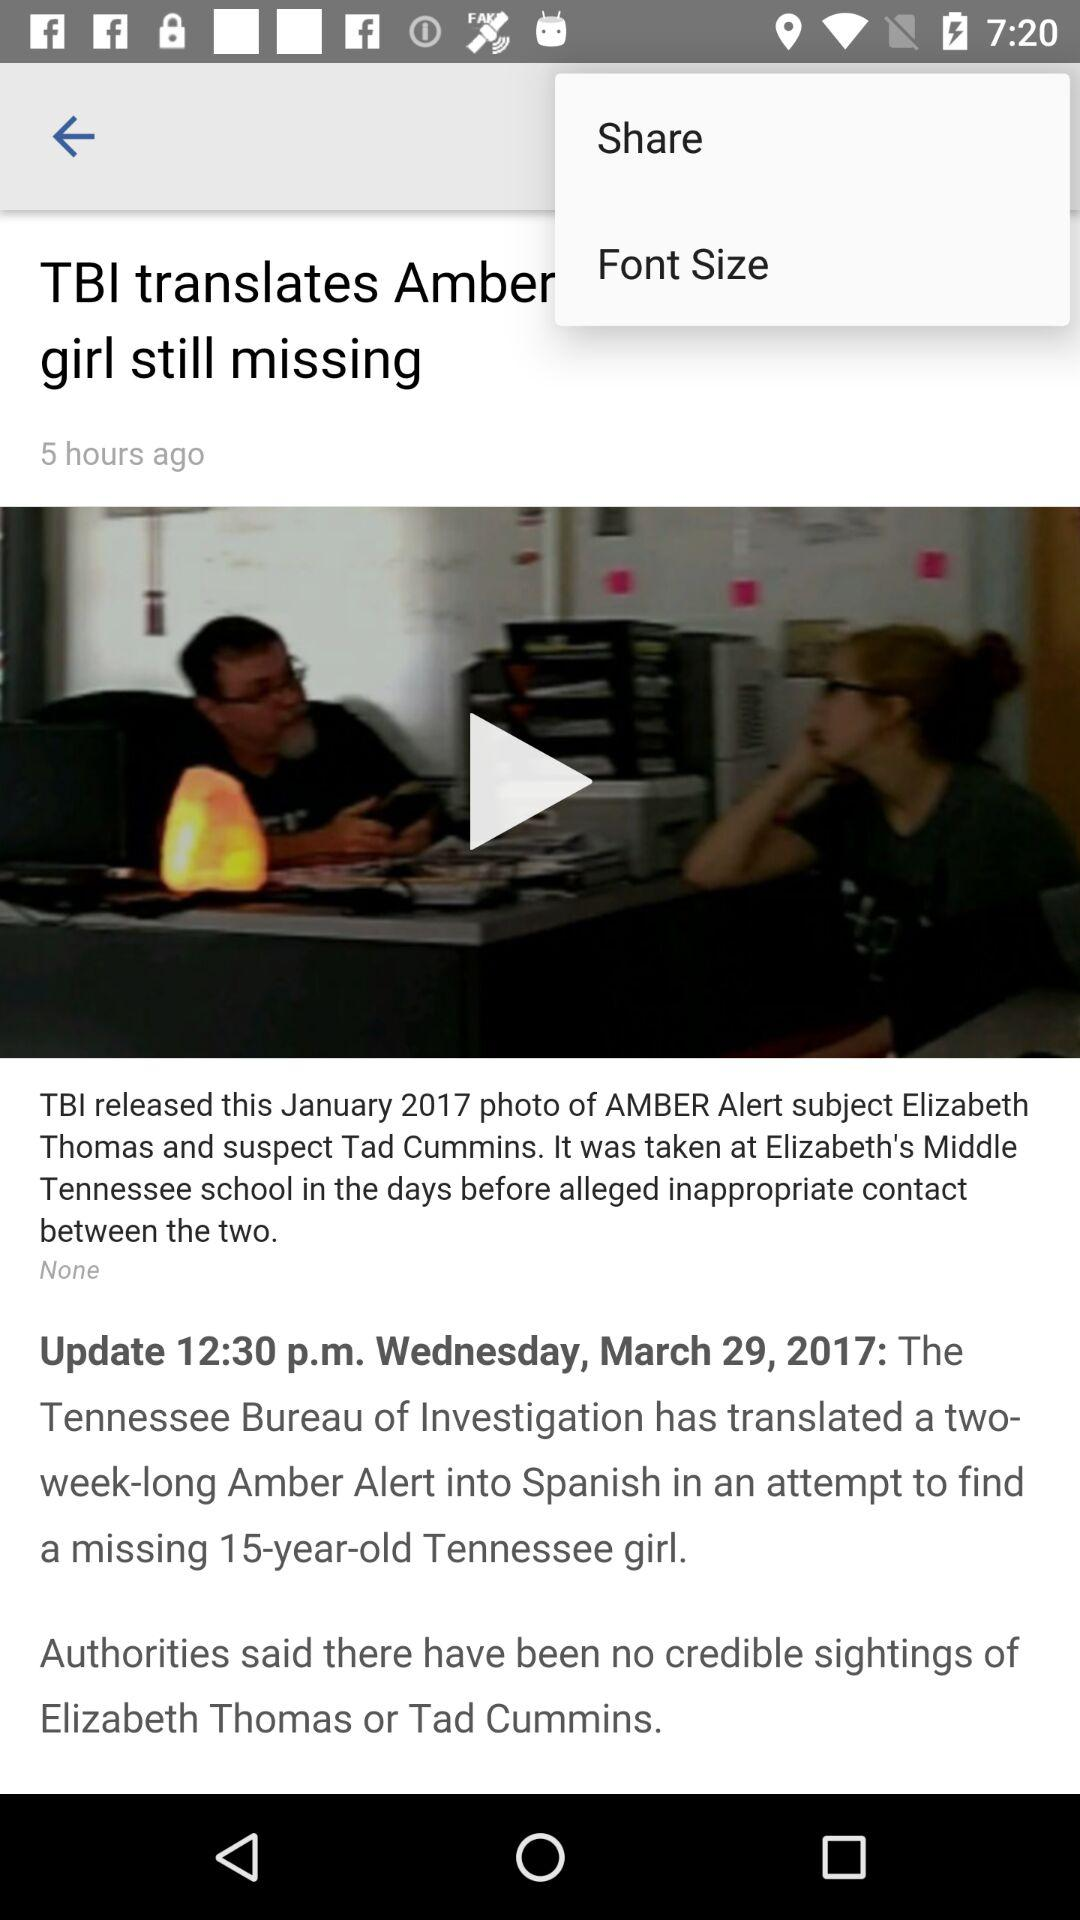On what date was the news updated? The news was updated on Wednesday, March 29, 2017. 